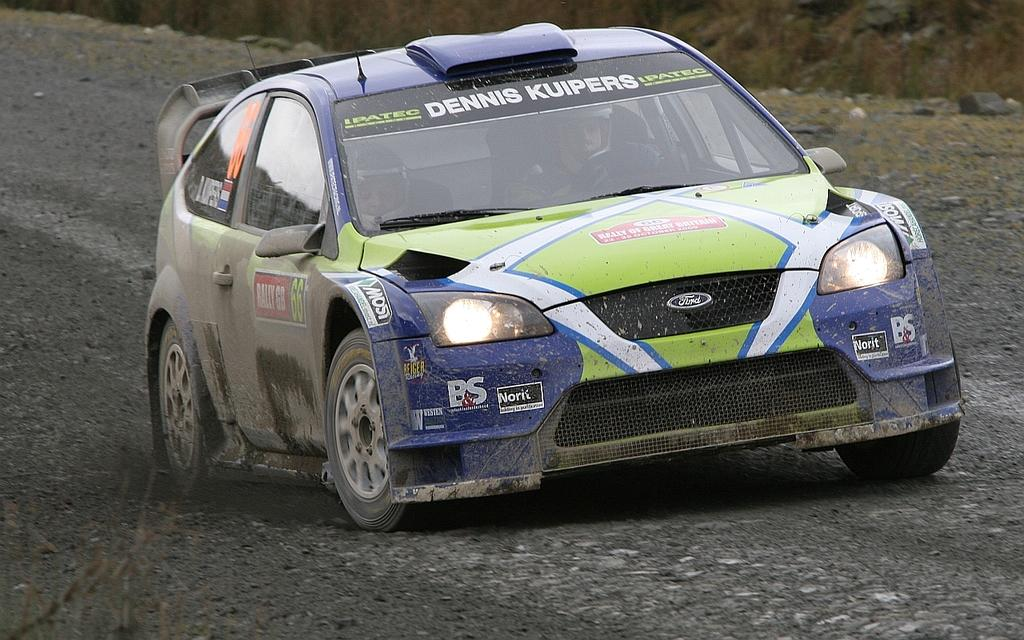What are the persons in the image doing? The persons in the image are riding in a car. Can you describe the car's position in the image? The car is on the ground in the image. What can be seen in the background of the image? There are stones visible in the background. What type of flower can be seen growing near the car in the image? There is no flower visible near the car in the image; only stones are present in the background. 